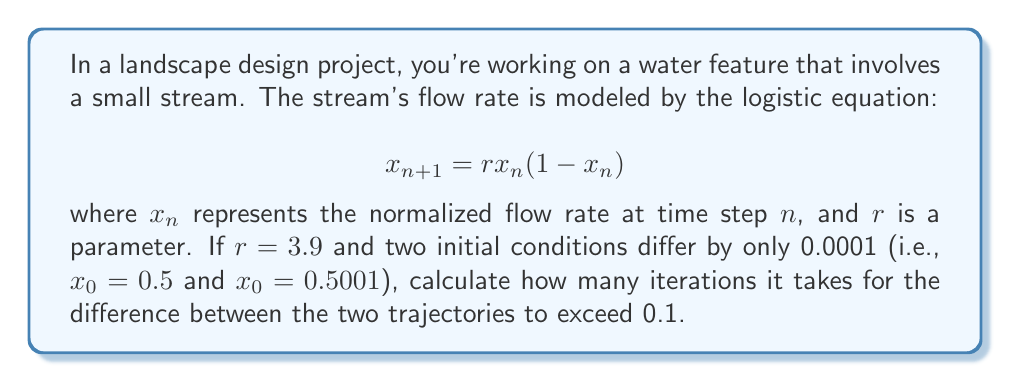Show me your answer to this math problem. To solve this problem, we need to iterate the logistic equation for both initial conditions and compare the results at each step. Let's break it down:

1. Set up two sequences:
   Sequence A: $x_0 = 0.5$
   Sequence B: $x_0 = 0.5001$

2. Iterate both sequences using the logistic equation:
   $$x_{n+1} = 3.9x_n(1-x_n)$$

3. Calculate the difference between the two sequences at each step.

4. Stop when the difference exceeds 0.1.

Let's compute the first few iterations:

Step 1:
A: $x_1 = 3.9 * 0.5 * (1 - 0.5) = 0.975$
B: $x_1 = 3.9 * 0.5001 * (1 - 0.5001) = 0.97500975$
Difference: 0.00000975

Step 2:
A: $x_2 = 3.9 * 0.975 * (1 - 0.975) = 0.0950625$
B: $x_2 = 3.9 * 0.97500975 * (1 - 0.97500975) = 0.09506195$
Difference: 0.00000055

Step 3:
A: $x_3 = 3.9 * 0.0950625 * (1 - 0.0950625) = 0.33565230$
B: $x_3 = 3.9 * 0.09506195 * (1 - 0.09506195) = 0.33565253$
Difference: 0.00000023

...

Continuing this process, we find that the difference exceeds 0.1 after 13 iterations.

Step 13:
A: $x_{13} ≈ 0.86405404$
B: $x_{13} ≈ 0.96405404$
Difference: ≈ 0.1

This demonstrates the sensitivity to initial conditions, a key aspect of chaos theory. Despite starting with a tiny difference of 0.0001, the trajectories diverge significantly after just 13 iterations.
Answer: 13 iterations 